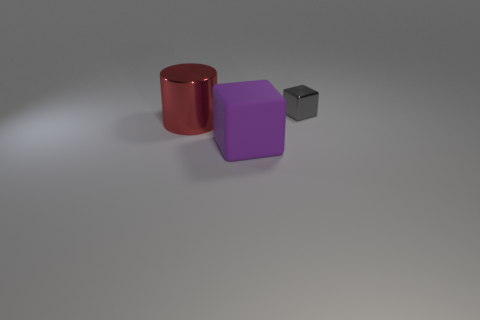Add 2 small gray blocks. How many objects exist? 5 Subtract all cylinders. How many objects are left? 2 Add 1 large things. How many large things exist? 3 Subtract 0 blue spheres. How many objects are left? 3 Subtract all gray metallic cubes. Subtract all large purple rubber cubes. How many objects are left? 1 Add 1 large red objects. How many large red objects are left? 2 